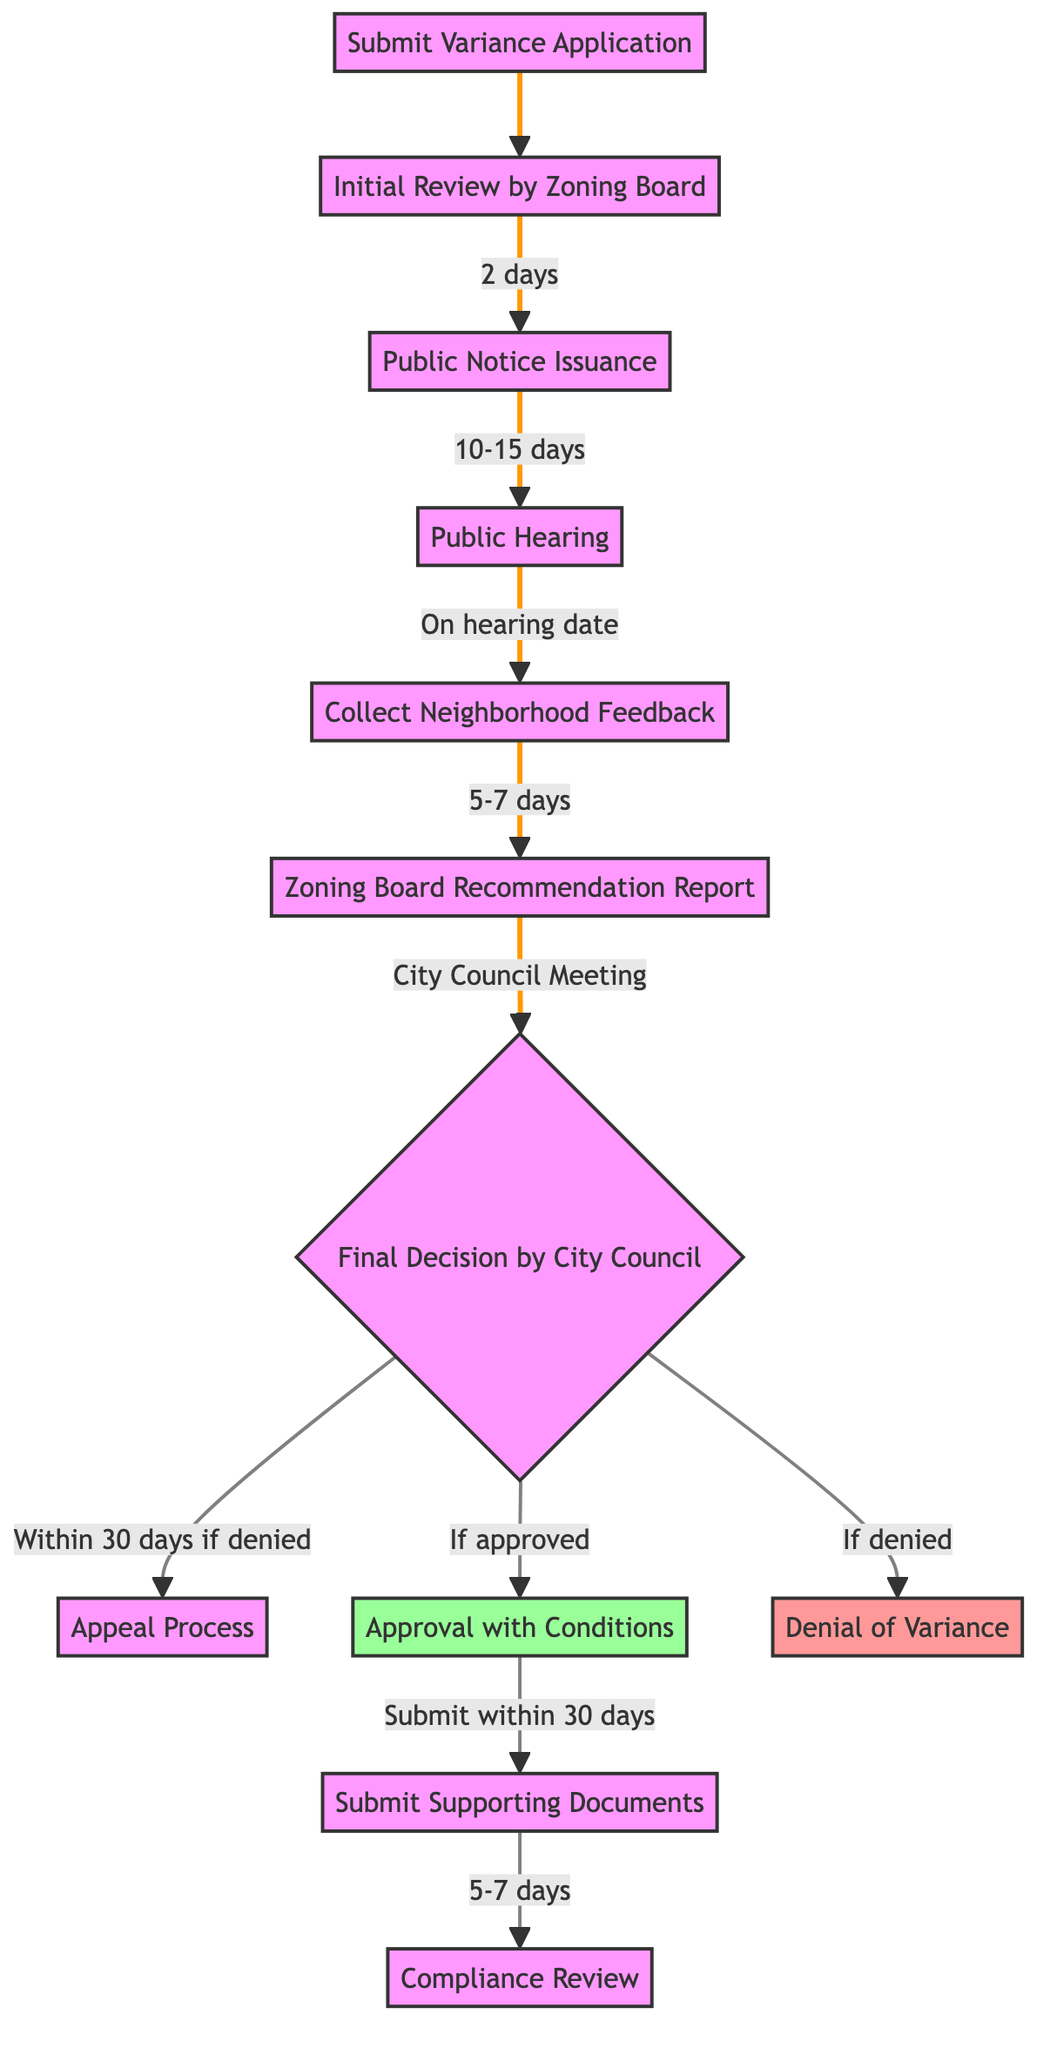What is the first step in the zoning law variance approval process? The first step displayed in the diagram is "Submit Variance Application," as it originates from the starting point of the flowchart.
Answer: Submit Variance Application How many days does the initial review by the zoning board take? The diagram indicates that the initial review by the zoning board is completed in "2 days," which is directly noted next to that process in the flowchart.
Answer: 2 days What happens after the public hearing? After the public hearing, the process involves "Collect Neighborhood Feedback" as the subsequent node in the flowchart, which follows immediately after the public hearing step.
Answer: Collect Neighborhood Feedback What is the timeline for the compliance review after approval with conditions? The compliance review occurs "5-7 days" after submitting supporting documents, which follows the submission step in the flowchart.
Answer: 5-7 days What decision can the city council make? The city council can make a "Final Decision," which branches out to either "Approval with Conditions" or "Denial of Variance," as highlighted in the flowchart.
Answer: Final Decision If the variance is approved, what must be submitted within 30 days? Following an approval, the next required step is "Submit Supporting Documents," which is noted to occur within 30 days of the approval process.
Answer: Submit Supporting Documents What happens if the variance is denied? If the variance is denied, the next step is the "Appeal Process," as indicated in the flowchart connecting the denied outcome back into the processes.
Answer: Appeal Process How many steps are there before the city council meeting? The flowchart outlines a total of "5 steps" leading up to the city council meeting from the initial application submission to obtaining the zoning board recommendation report.
Answer: 5 steps What specific review occurs after submitting supporting documents? Following the submission of supporting documents, the next step is the "Compliance Review," as evidenced in the diagram subsequent to the supporting documents step.
Answer: Compliance Review 